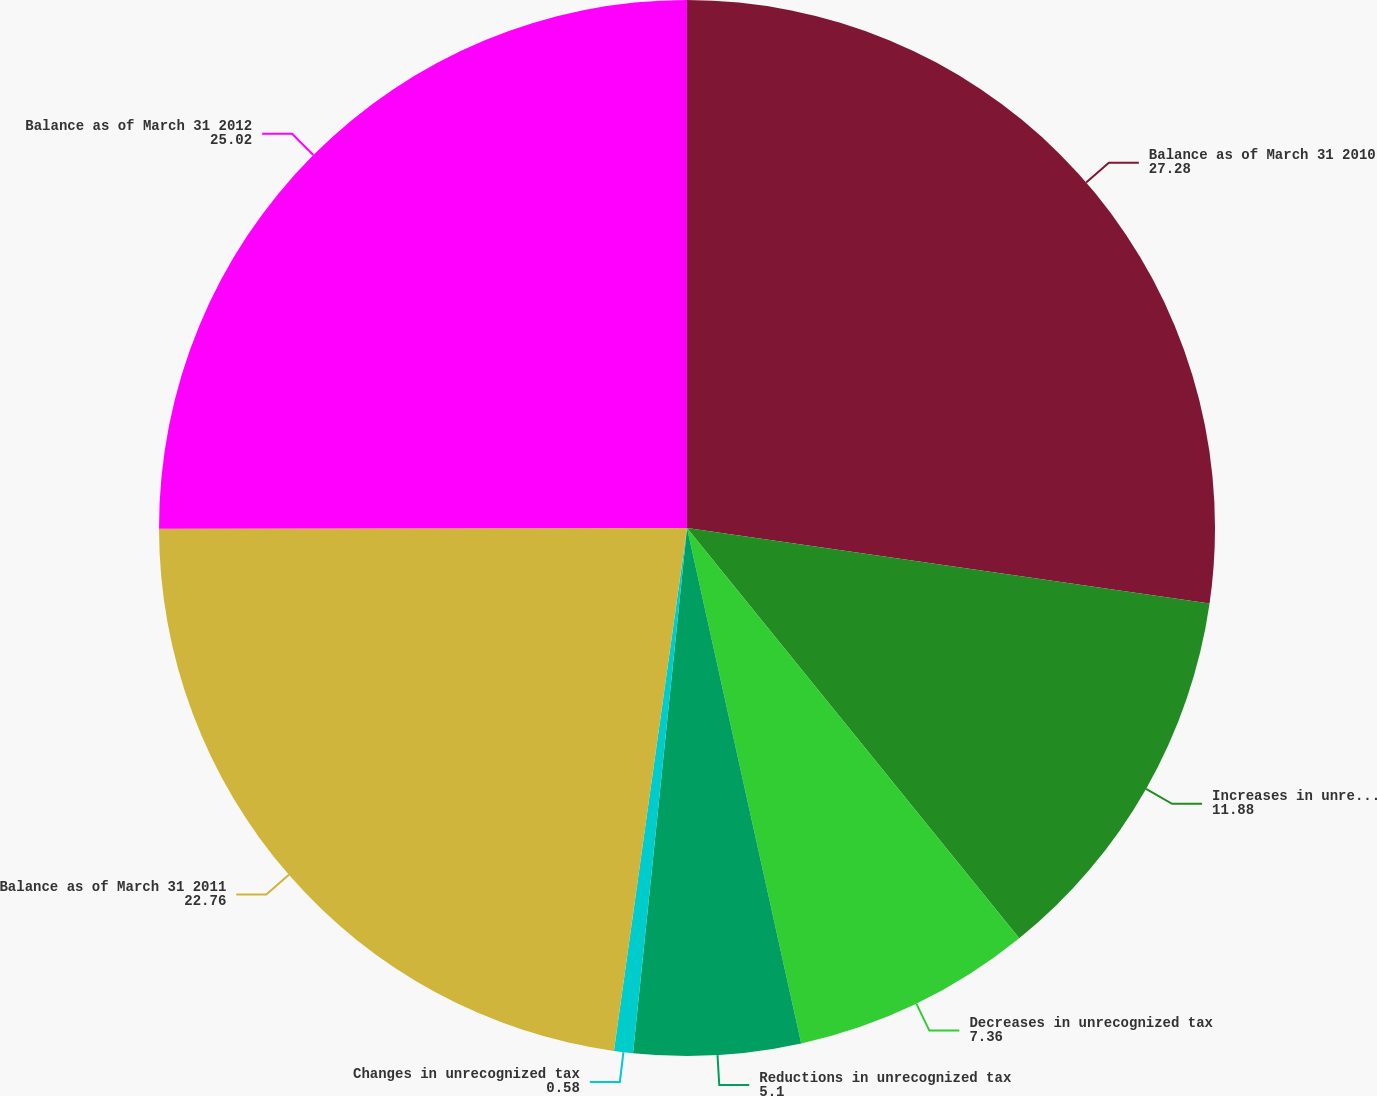Convert chart to OTSL. <chart><loc_0><loc_0><loc_500><loc_500><pie_chart><fcel>Balance as of March 31 2010<fcel>Increases in unrecognized tax<fcel>Decreases in unrecognized tax<fcel>Reductions in unrecognized tax<fcel>Changes in unrecognized tax<fcel>Balance as of March 31 2011<fcel>Balance as of March 31 2012<nl><fcel>27.28%<fcel>11.88%<fcel>7.36%<fcel>5.1%<fcel>0.58%<fcel>22.76%<fcel>25.02%<nl></chart> 